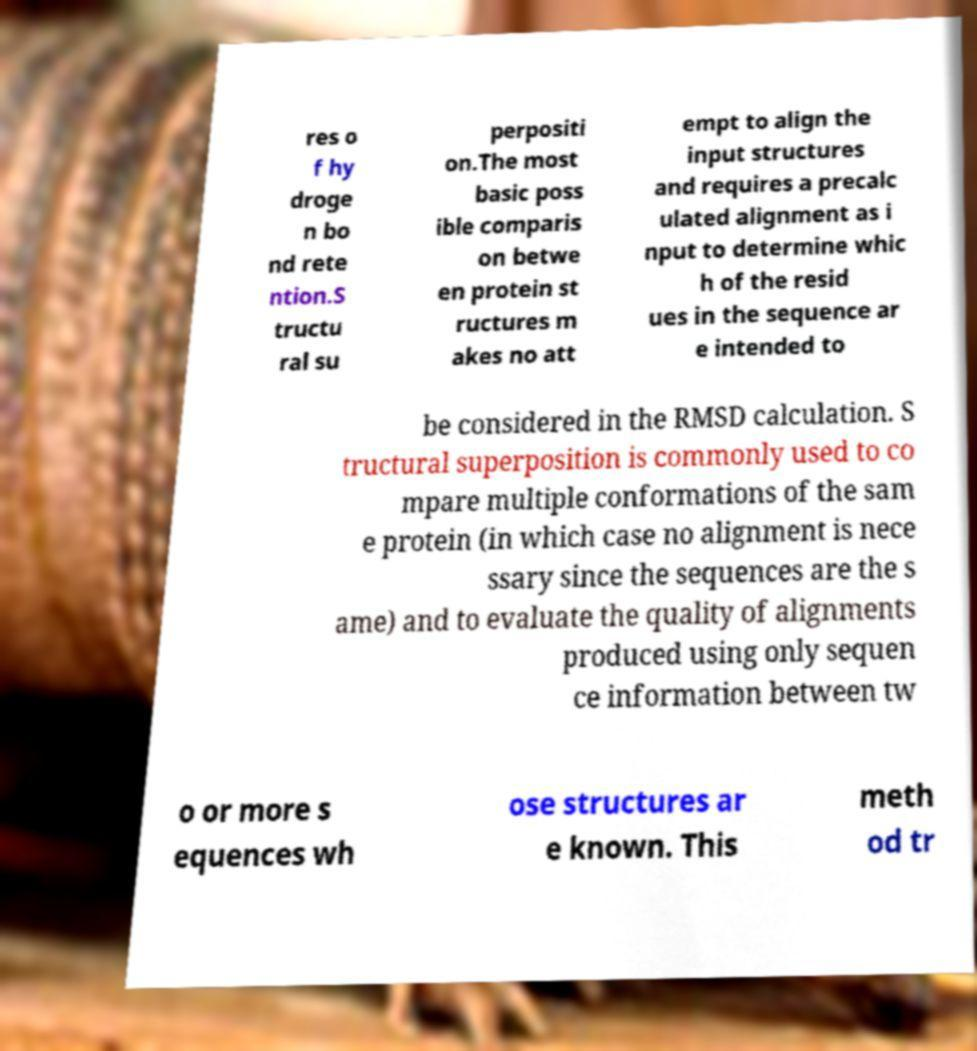Can you accurately transcribe the text from the provided image for me? res o f hy droge n bo nd rete ntion.S tructu ral su perpositi on.The most basic poss ible comparis on betwe en protein st ructures m akes no att empt to align the input structures and requires a precalc ulated alignment as i nput to determine whic h of the resid ues in the sequence ar e intended to be considered in the RMSD calculation. S tructural superposition is commonly used to co mpare multiple conformations of the sam e protein (in which case no alignment is nece ssary since the sequences are the s ame) and to evaluate the quality of alignments produced using only sequen ce information between tw o or more s equences wh ose structures ar e known. This meth od tr 